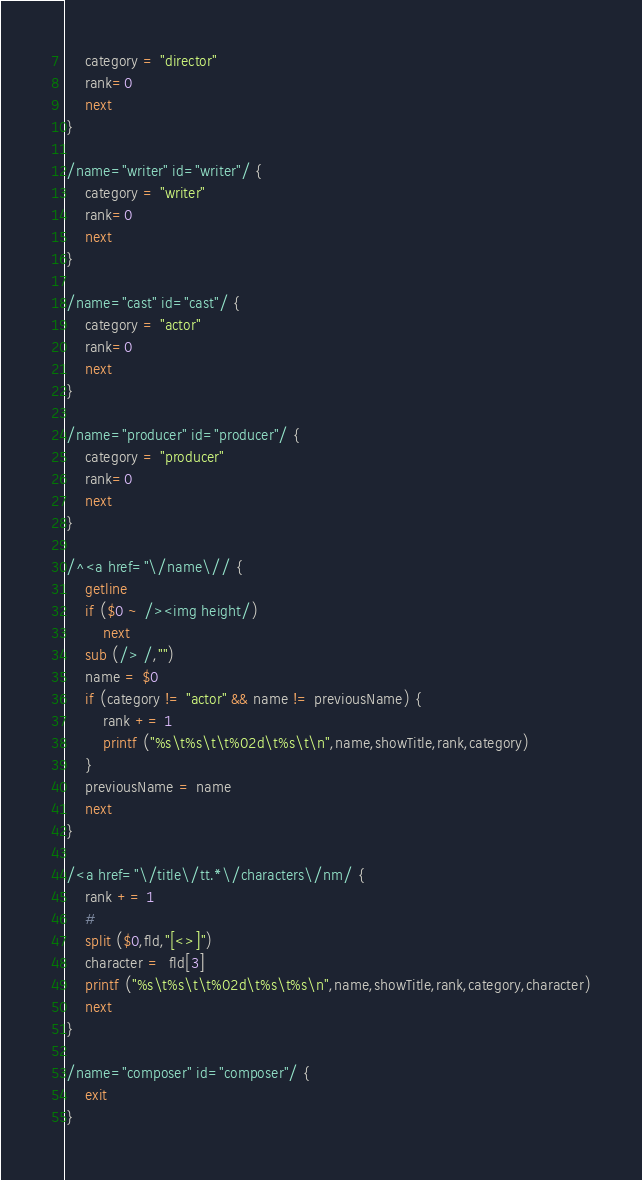Convert code to text. <code><loc_0><loc_0><loc_500><loc_500><_Awk_>    category = "director"
    rank=0
    next
}

/name="writer" id="writer"/ {
    category = "writer"
    rank=0
    next
}

/name="cast" id="cast"/ {
    category = "actor"
    rank=0
    next
}

/name="producer" id="producer"/ {
    category = "producer"
    rank=0
    next
}

/^<a href="\/name\// {
    getline
    if ($0 ~ /><img height/)
        next
    sub (/> /,"")
    name = $0
    if (category != "actor" && name != previousName) {
        rank += 1
        printf ("%s\t%s\t\t%02d\t%s\t\n",name,showTitle,rank,category)
    }
    previousName = name
    next
}

/<a href="\/title\/tt.*\/characters\/nm/ {
    rank += 1
    #
    split ($0,fld,"[<>]")
    character =  fld[3]
    printf ("%s\t%s\t\t%02d\t%s\t%s\n",name,showTitle,rank,category,character)
    next
}

/name="composer" id="composer"/ {
    exit
}
</code> 